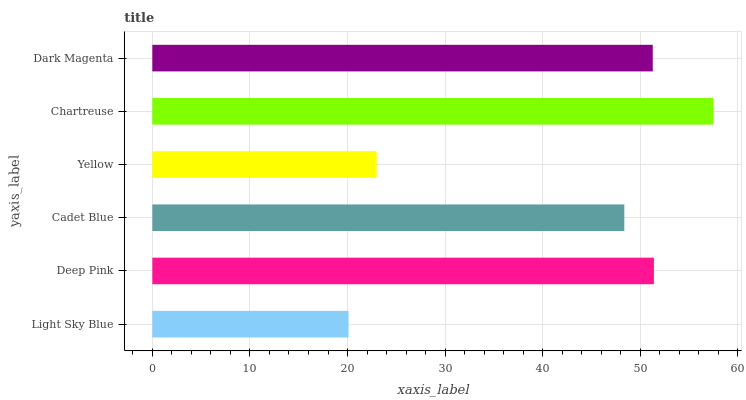Is Light Sky Blue the minimum?
Answer yes or no. Yes. Is Chartreuse the maximum?
Answer yes or no. Yes. Is Deep Pink the minimum?
Answer yes or no. No. Is Deep Pink the maximum?
Answer yes or no. No. Is Deep Pink greater than Light Sky Blue?
Answer yes or no. Yes. Is Light Sky Blue less than Deep Pink?
Answer yes or no. Yes. Is Light Sky Blue greater than Deep Pink?
Answer yes or no. No. Is Deep Pink less than Light Sky Blue?
Answer yes or no. No. Is Dark Magenta the high median?
Answer yes or no. Yes. Is Cadet Blue the low median?
Answer yes or no. Yes. Is Light Sky Blue the high median?
Answer yes or no. No. Is Light Sky Blue the low median?
Answer yes or no. No. 